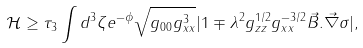Convert formula to latex. <formula><loc_0><loc_0><loc_500><loc_500>\mathcal { H } \geq \tau _ { 3 } \int d ^ { 3 } \zeta e ^ { - \phi } \sqrt { g _ { 0 0 } g _ { x x } ^ { 3 } } | 1 \mp \lambda ^ { 2 } g _ { z z } ^ { 1 / 2 } g _ { x x } ^ { - 3 / 2 } \vec { B } . \vec { \nabla } \sigma | ,</formula> 